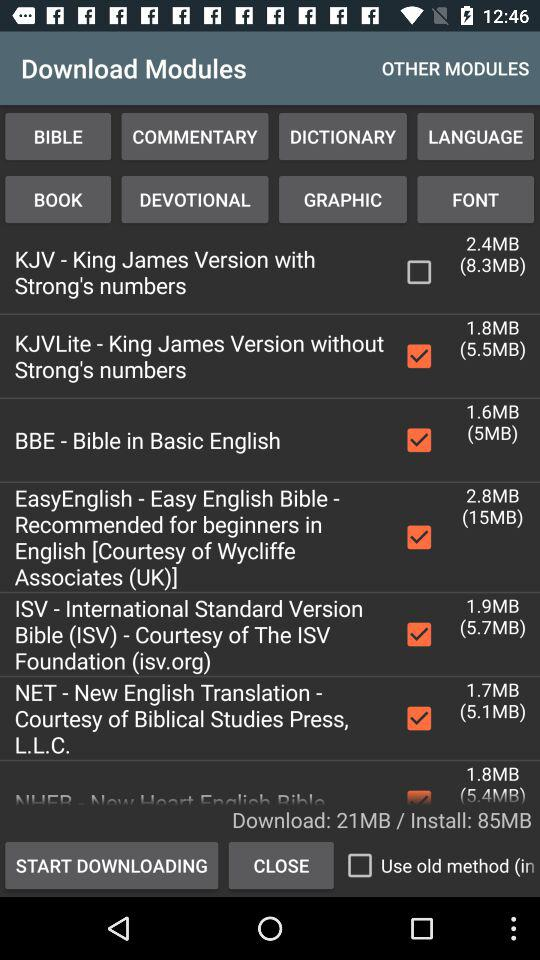What is the size of the KJV file?
When the provided information is insufficient, respond with <no answer>. <no answer> 